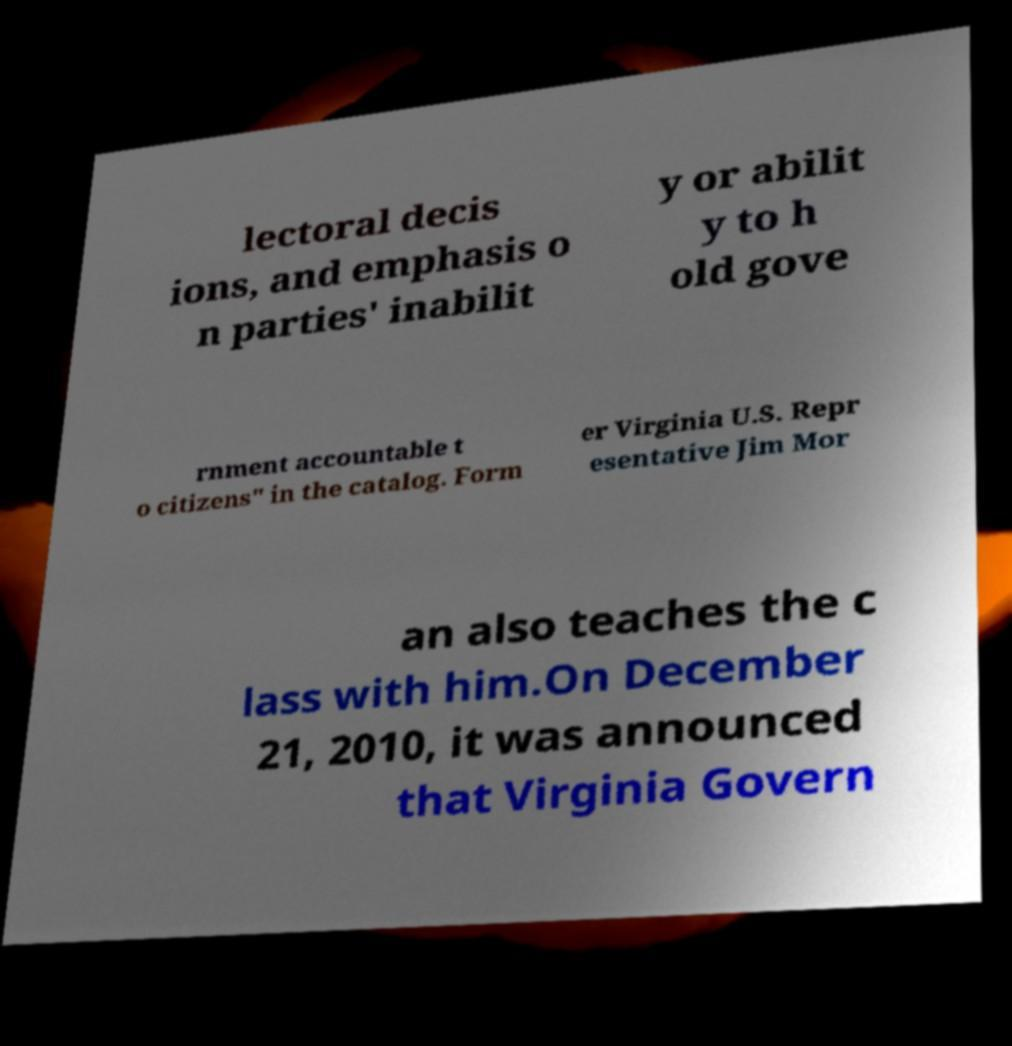Could you assist in decoding the text presented in this image and type it out clearly? lectoral decis ions, and emphasis o n parties' inabilit y or abilit y to h old gove rnment accountable t o citizens" in the catalog. Form er Virginia U.S. Repr esentative Jim Mor an also teaches the c lass with him.On December 21, 2010, it was announced that Virginia Govern 